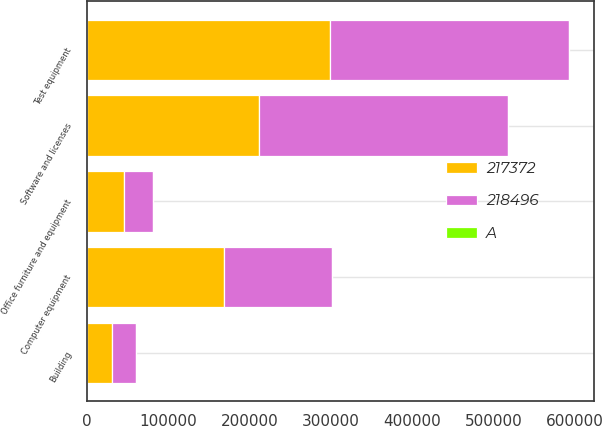Convert chart. <chart><loc_0><loc_0><loc_500><loc_500><stacked_bar_chart><ecel><fcel>Building<fcel>Test equipment<fcel>Software and licenses<fcel>Computer equipment<fcel>Office furniture and equipment<nl><fcel>217372<fcel>30869<fcel>299506<fcel>211339<fcel>168455<fcel>45521<nl><fcel>218496<fcel>29326<fcel>293807<fcel>306699<fcel>132896<fcel>36239<nl><fcel>A<fcel>325<fcel>35<fcel>35<fcel>3<fcel>5<nl></chart> 